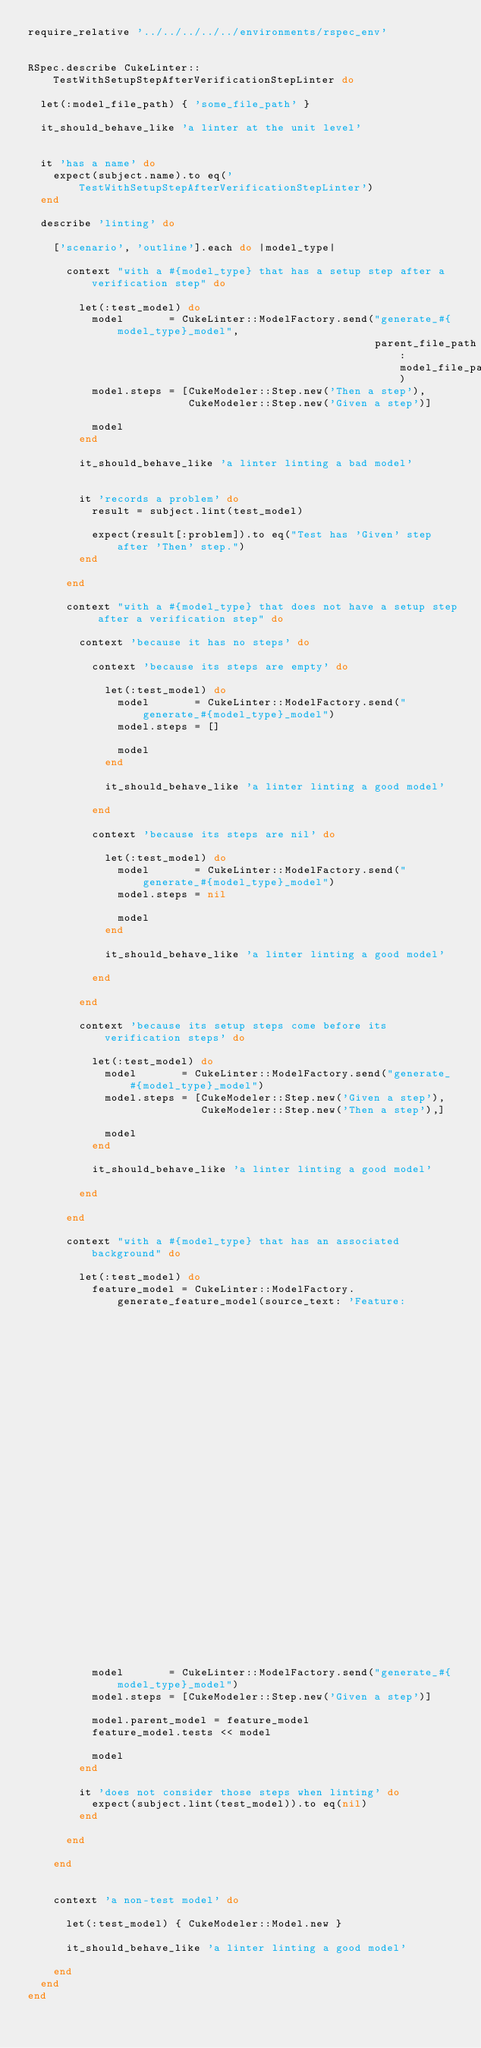<code> <loc_0><loc_0><loc_500><loc_500><_Ruby_>require_relative '../../../../../environments/rspec_env'


RSpec.describe CukeLinter::TestWithSetupStepAfterVerificationStepLinter do

  let(:model_file_path) { 'some_file_path' }

  it_should_behave_like 'a linter at the unit level'


  it 'has a name' do
    expect(subject.name).to eq('TestWithSetupStepAfterVerificationStepLinter')
  end

  describe 'linting' do

    ['scenario', 'outline'].each do |model_type|

      context "with a #{model_type} that has a setup step after a verification step" do

        let(:test_model) do
          model       = CukeLinter::ModelFactory.send("generate_#{model_type}_model",
                                                      parent_file_path: model_file_path)
          model.steps = [CukeModeler::Step.new('Then a step'),
                         CukeModeler::Step.new('Given a step')]

          model
        end

        it_should_behave_like 'a linter linting a bad model'


        it 'records a problem' do
          result = subject.lint(test_model)

          expect(result[:problem]).to eq("Test has 'Given' step after 'Then' step.")
        end

      end

      context "with a #{model_type} that does not have a setup step after a verification step" do

        context 'because it has no steps' do

          context 'because its steps are empty' do

            let(:test_model) do
              model       = CukeLinter::ModelFactory.send("generate_#{model_type}_model")
              model.steps = []

              model
            end

            it_should_behave_like 'a linter linting a good model'

          end

          context 'because its steps are nil' do

            let(:test_model) do
              model       = CukeLinter::ModelFactory.send("generate_#{model_type}_model")
              model.steps = nil

              model
            end

            it_should_behave_like 'a linter linting a good model'

          end

        end

        context 'because its setup steps come before its verification steps' do

          let(:test_model) do
            model       = CukeLinter::ModelFactory.send("generate_#{model_type}_model")
            model.steps = [CukeModeler::Step.new('Given a step'),
                           CukeModeler::Step.new('Then a step'),]

            model
          end

          it_should_behave_like 'a linter linting a good model'

        end

      end

      context "with a #{model_type} that has an associated background" do

        let(:test_model) do
          feature_model = CukeLinter::ModelFactory.generate_feature_model(source_text: 'Feature:
                                                                                          Background:
                                                                                            Given a step
                                                                                            Then a step
                                                                                            Given a step
                                                                                            Then a step')

          model       = CukeLinter::ModelFactory.send("generate_#{model_type}_model")
          model.steps = [CukeModeler::Step.new('Given a step')]

          model.parent_model = feature_model
          feature_model.tests << model

          model
        end

        it 'does not consider those steps when linting' do
          expect(subject.lint(test_model)).to eq(nil)
        end

      end

    end


    context 'a non-test model' do

      let(:test_model) { CukeModeler::Model.new }

      it_should_behave_like 'a linter linting a good model'

    end
  end
end
</code> 